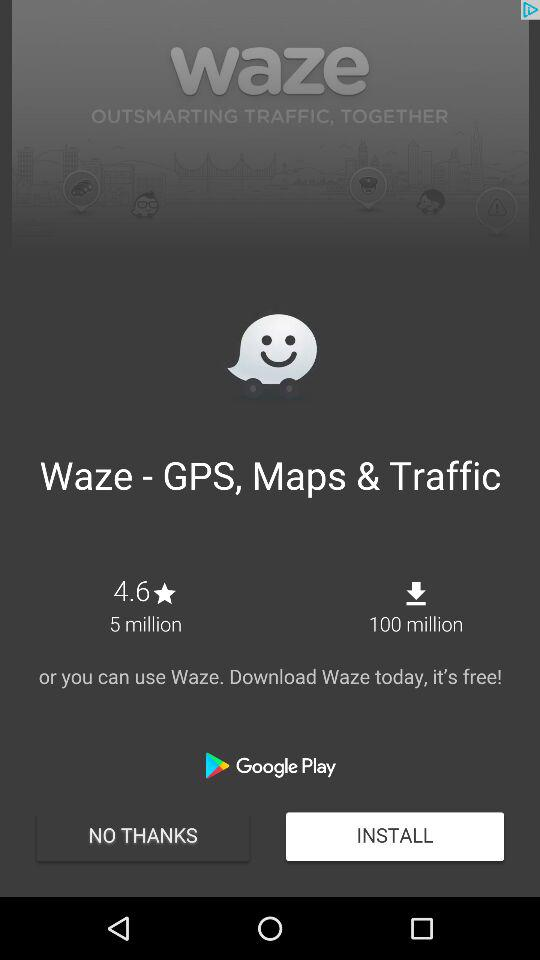How many more downloads does the Waze app have than the number of people who have rated it?
Answer the question using a single word or phrase. 95 million 